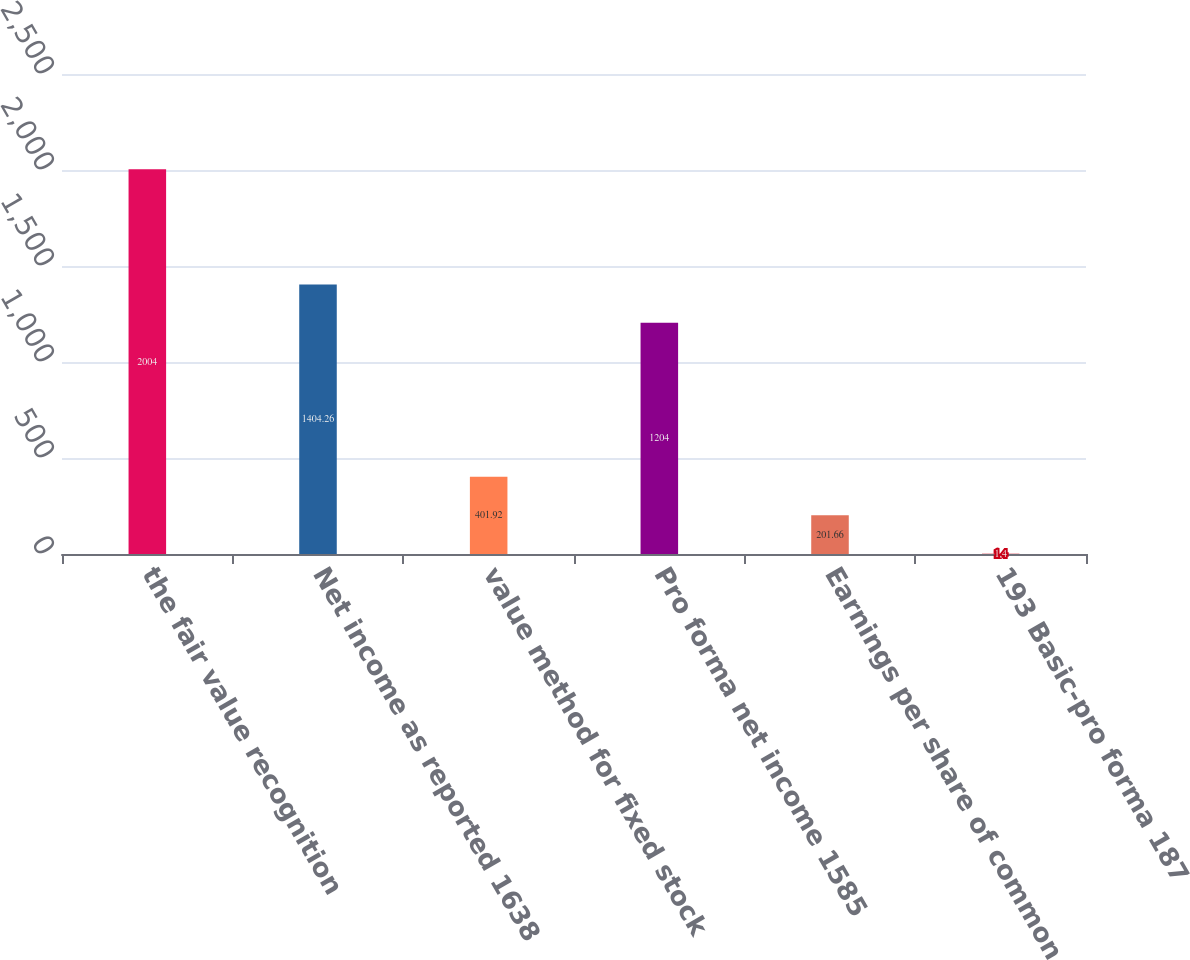Convert chart to OTSL. <chart><loc_0><loc_0><loc_500><loc_500><bar_chart><fcel>the fair value recognition<fcel>Net income as reported 1638<fcel>value method for fixed stock<fcel>Pro forma net income 1585<fcel>Earnings per share of common<fcel>193 Basic-pro forma 187<nl><fcel>2004<fcel>1404.26<fcel>401.92<fcel>1204<fcel>201.66<fcel>1.4<nl></chart> 